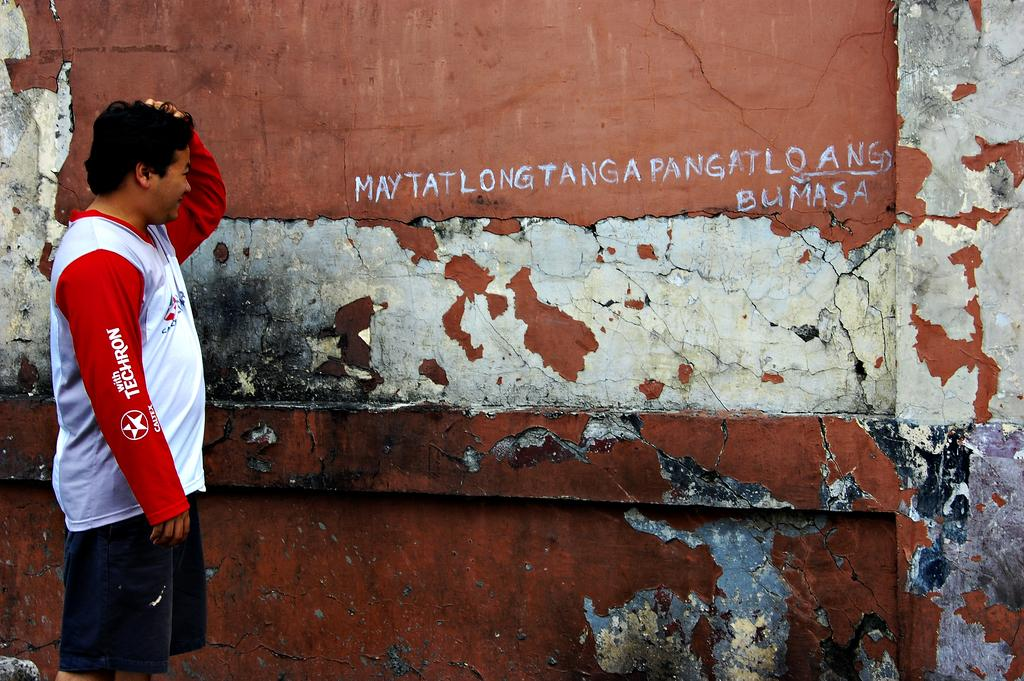<image>
Give a short and clear explanation of the subsequent image. A man wearing a Caltex shirt is standing in front of a faded wall with writing on it and has his hand on his head in apparent confusion. 